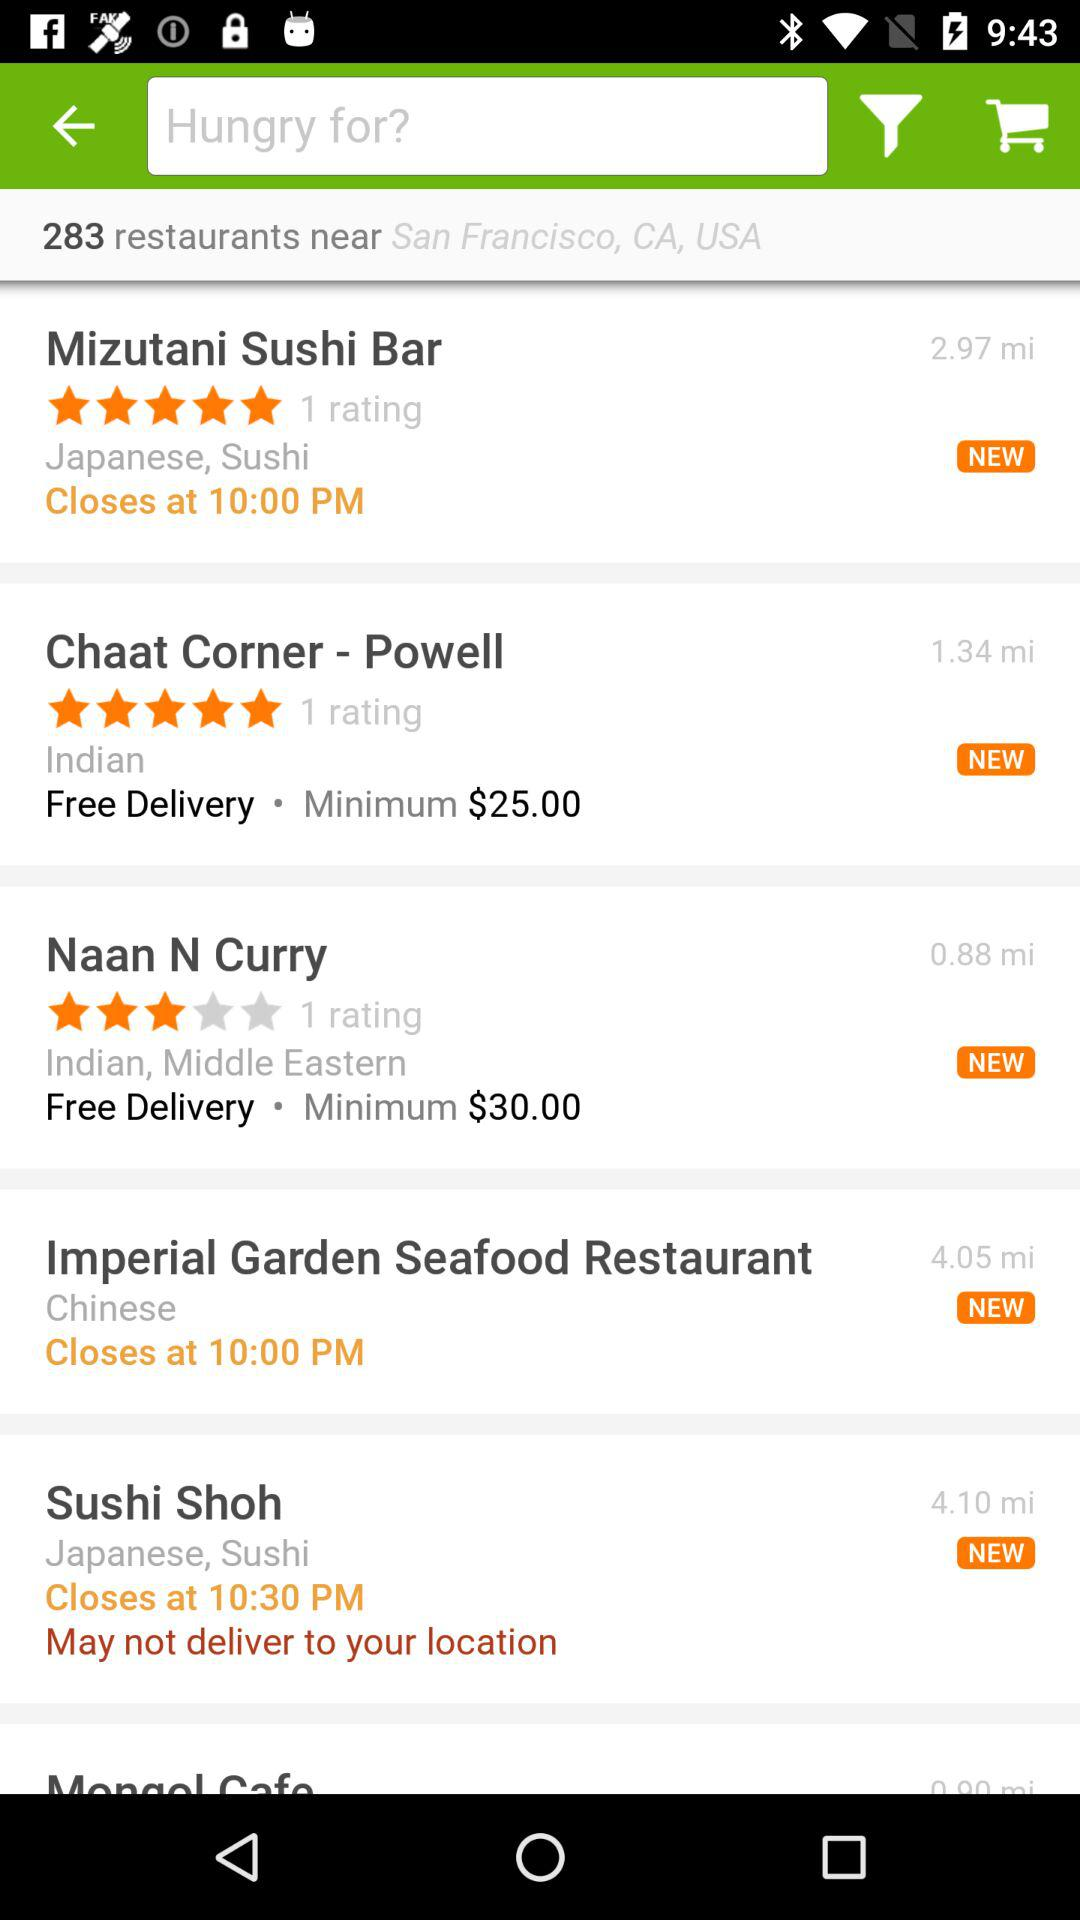What is the total number of restaurants near San Francisco, CA, USA? The total number of restaurants is 283. 